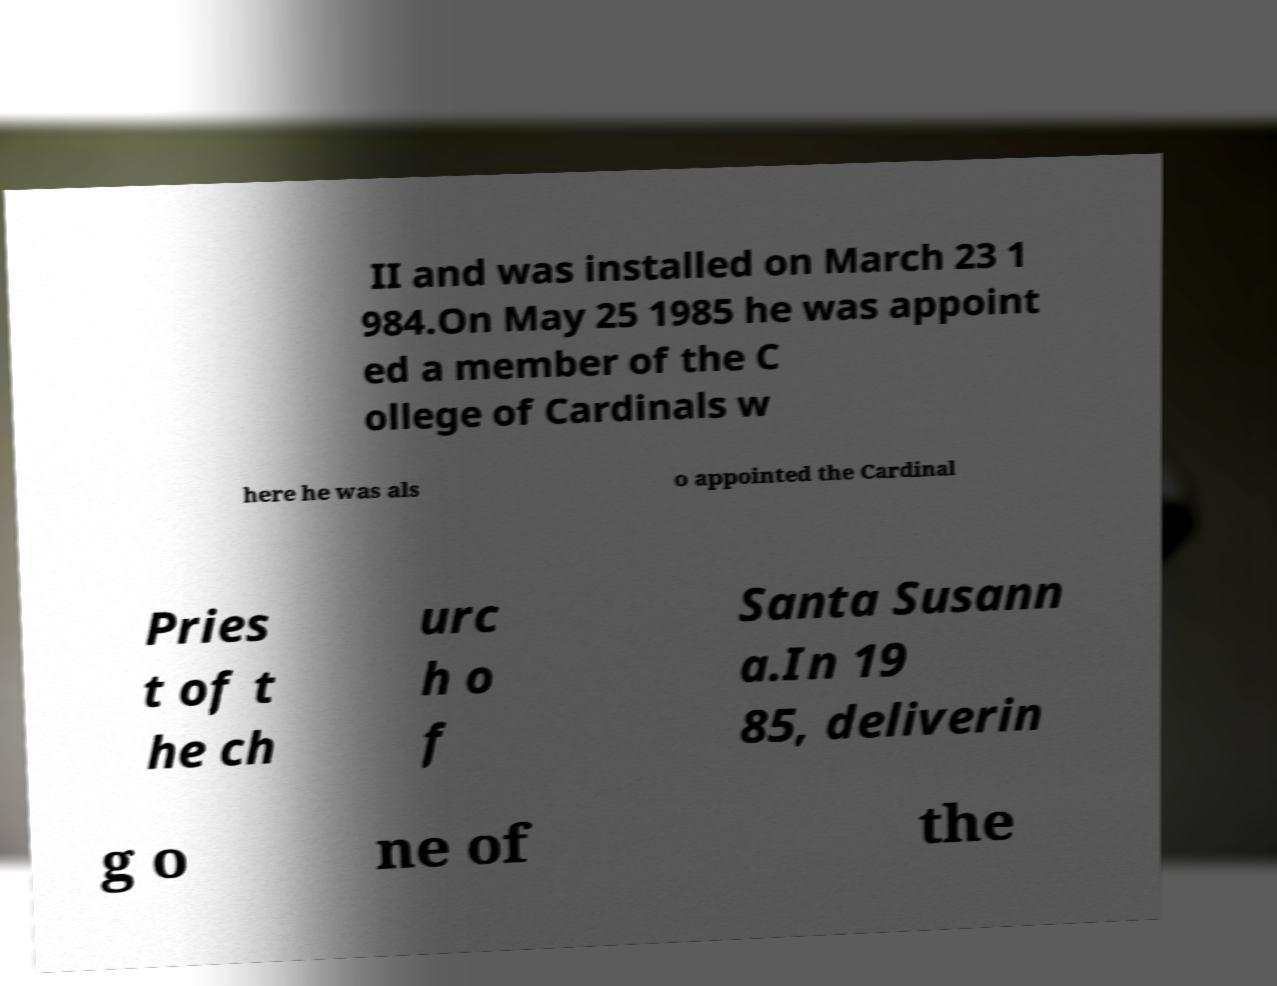Could you assist in decoding the text presented in this image and type it out clearly? II and was installed on March 23 1 984.On May 25 1985 he was appoint ed a member of the C ollege of Cardinals w here he was als o appointed the Cardinal Pries t of t he ch urc h o f Santa Susann a.In 19 85, deliverin g o ne of the 